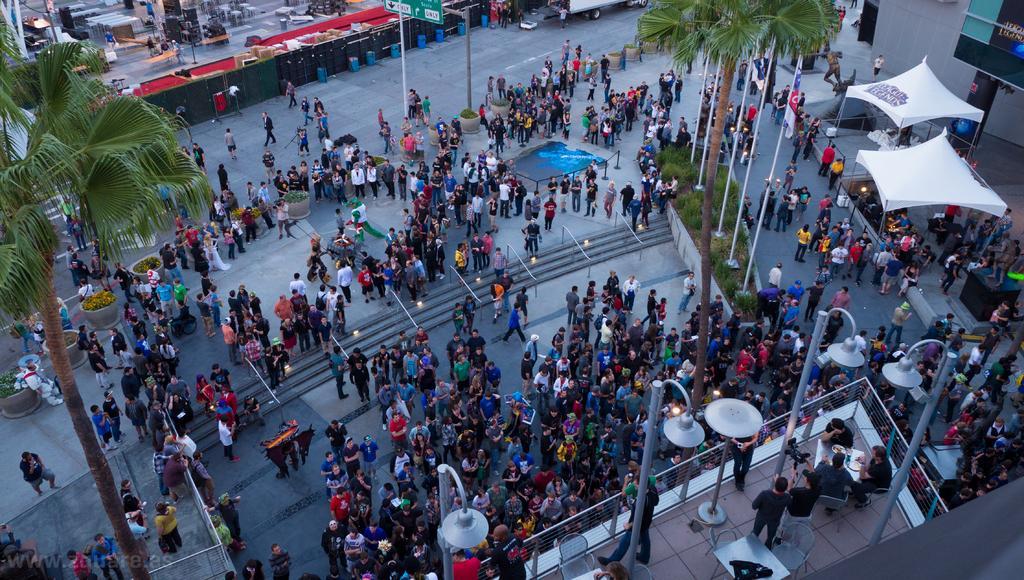Can you describe this image briefly? In this image I can see many people with different color dresses. I can see the poles, many trees and I can see few people are sitting on the chairs. To the right I can see the tents and the buildings. In the background I can see few more people, vehicles and many objects. 